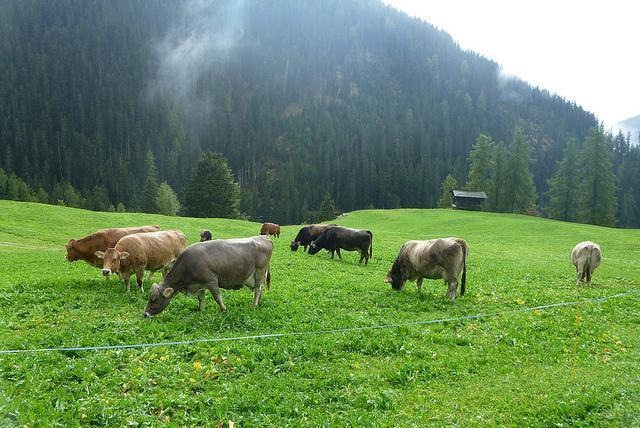How many cows in the field?
Give a very brief answer. 9. How many cows are in the photo?
Give a very brief answer. 3. How many of the bikes are blue?
Give a very brief answer. 0. 